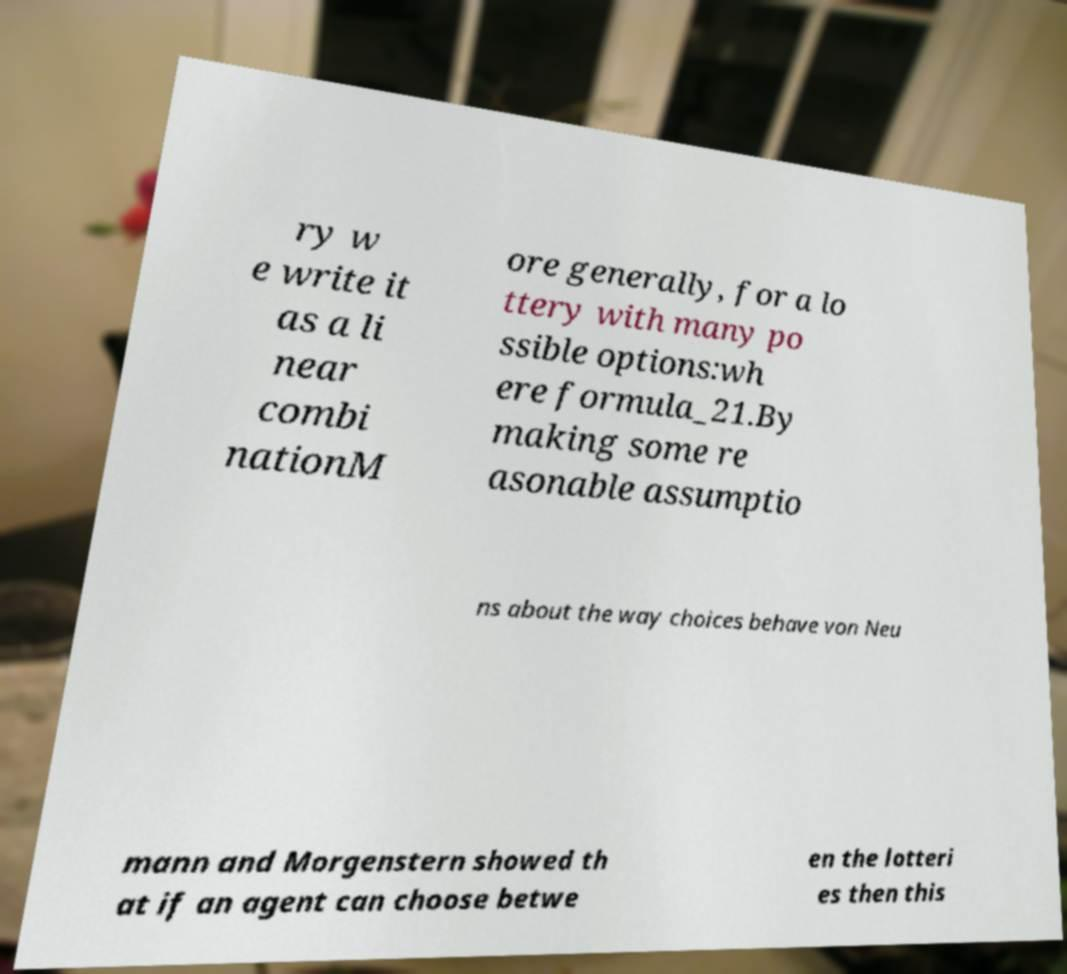What messages or text are displayed in this image? I need them in a readable, typed format. ry w e write it as a li near combi nationM ore generally, for a lo ttery with many po ssible options:wh ere formula_21.By making some re asonable assumptio ns about the way choices behave von Neu mann and Morgenstern showed th at if an agent can choose betwe en the lotteri es then this 